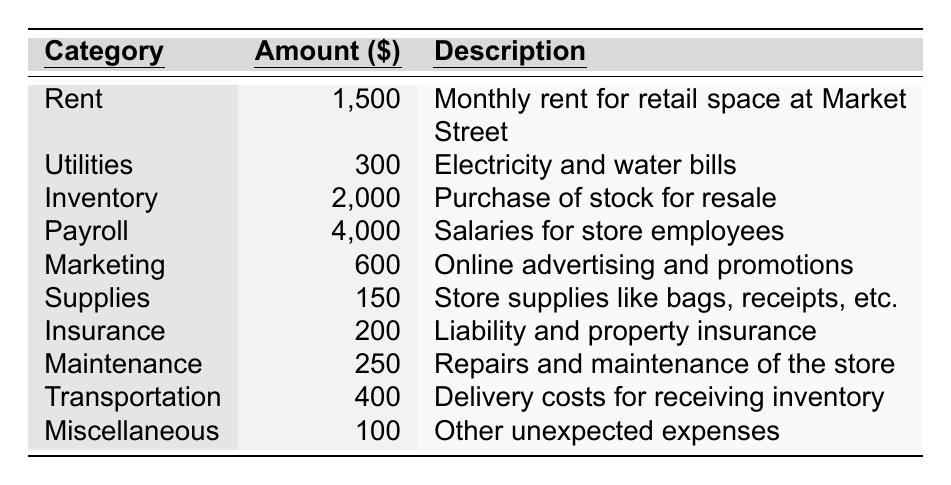What is the total amount spent on Payroll? The table shows the amount spent on Payroll is $4,000. There is no calculation needed since this is a direct retrieval from the table.
Answer: 4,000 What category has the lowest expense, and how much is it? The Supplies category has the lowest expense of $150, as seen in the table. This can be identified by comparing all the expense amounts listed.
Answer: Supplies, 150 What is the average monthly expense across all categories? The total amount spent across all categories is $9,600. There are 10 categories in total. To find the average, divide $9,600 by 10, which equals $960.
Answer: 960 Is the amount spent on Utilities more than that on Miscellaneous? The Utilities amount is $300, and the Miscellaneous amount is $100. Since $300 is greater than $100, the statement is true.
Answer: Yes What is the total expense for Inventory and Marketing combined? The amount for Inventory is $2,000 and for Marketing is $600. Adding these two amounts gives: $2,000 + $600 = $2,600.
Answer: 2,600 If we exclude Payroll, what is the total expense for all other categories? The total expenses excluding Payroll can be calculated by subtracting $4,000 from the overall total of $9,600. Therefore, $9,600 - $4,000 = $5,600.
Answer: 5,600 What percentage of the total expenses does Rent represent? First, calculate the total expenses: $9,600. The Rent amount is $1,500. To find the percentage, (1,500 / 9,600) * 100 = 15.625%. Thus, Rent accounts for approximately 15.63% of total expenses.
Answer: 15.63% Among all categories, which one represents the largest amount, and how much is it? The Payroll category has the largest amount, which is $4,000, as identified from the data presented in the table.
Answer: Payroll, 4,000 What are the total amounts spent on Marketing and Transportation together? The Marketing expense is $600 and the Transportation expense is $400. Adding these two amounts gives $600 + $400 = $1,000.
Answer: 1,000 Is the total expense for Insurance greater than the expense for Maintenance? The Insurance expense is $200, and the Maintenance expense is $250. Since $200 is less than $250, the statement is false.
Answer: No 